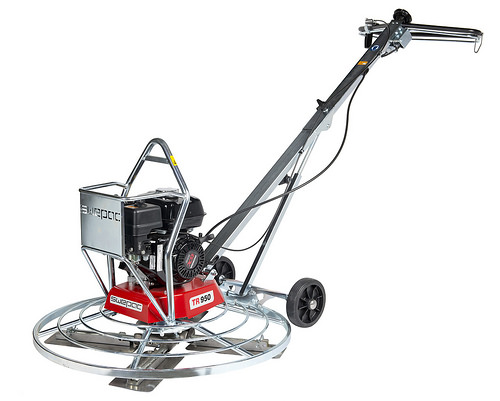<image>
Can you confirm if the handles is in front of the wheel? No. The handles is not in front of the wheel. The spatial positioning shows a different relationship between these objects. 